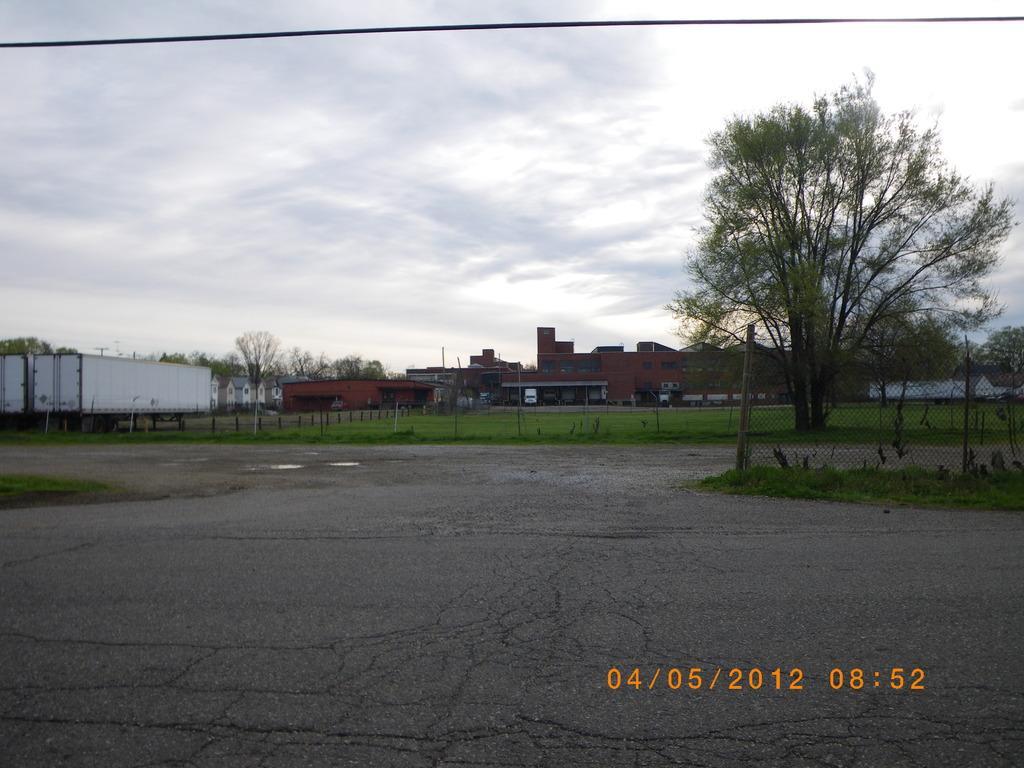Could you give a brief overview of what you see in this image? In this image I can see the ground, some grass on the ground, few poles, few containers which are white in color, the fencing, few trees, few vehicles and few buildings. In the background I can see the sky. 